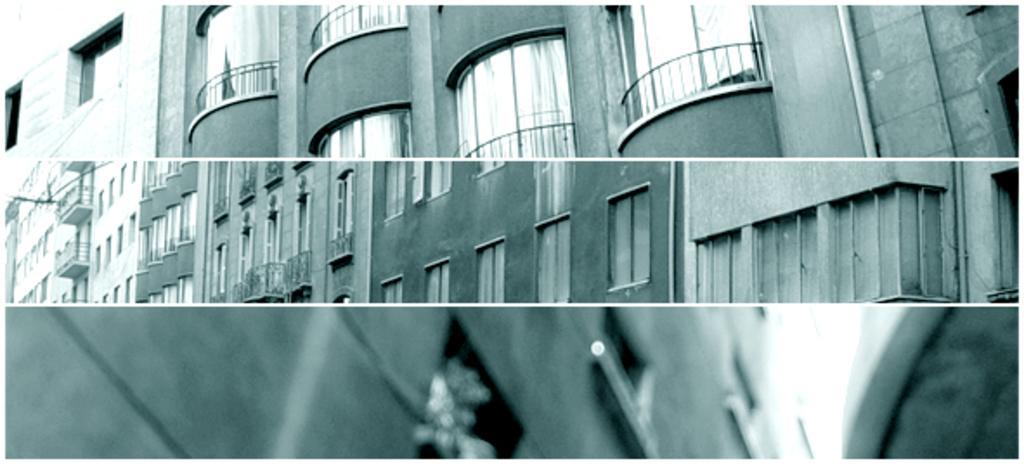In one or two sentences, can you explain what this image depicts? In this picture I can see the collage of images and I see number of buildings and I see that this image is of black and white in color. 